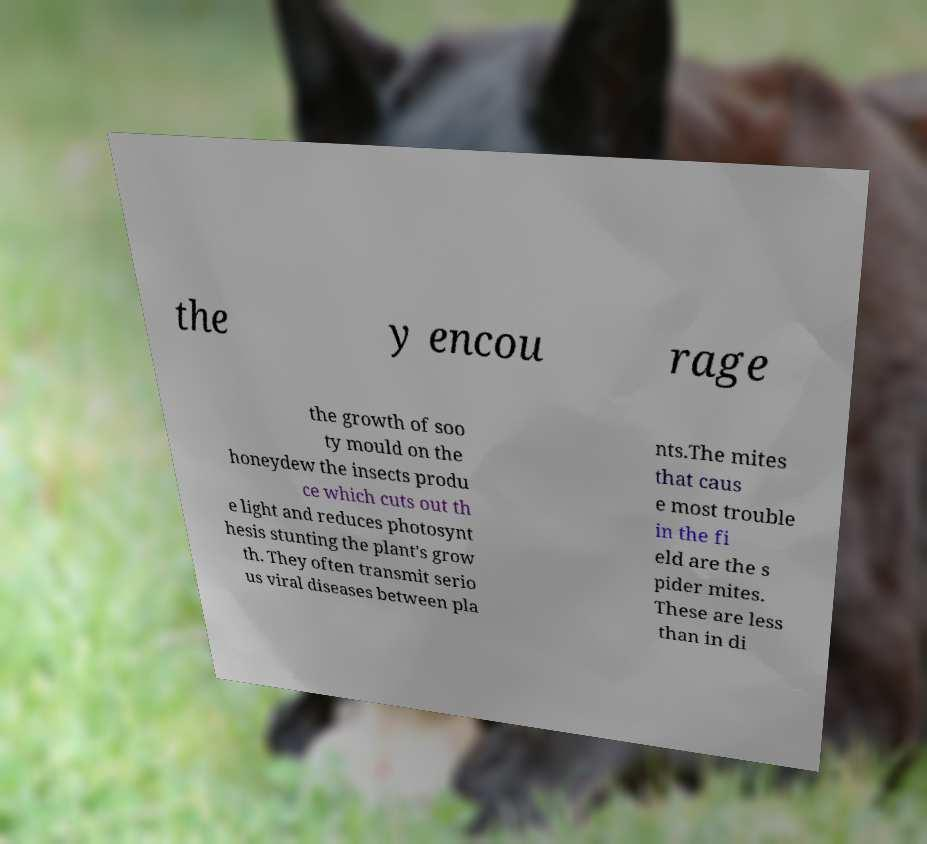What messages or text are displayed in this image? I need them in a readable, typed format. the y encou rage the growth of soo ty mould on the honeydew the insects produ ce which cuts out th e light and reduces photosynt hesis stunting the plant's grow th. They often transmit serio us viral diseases between pla nts.The mites that caus e most trouble in the fi eld are the s pider mites. These are less than in di 